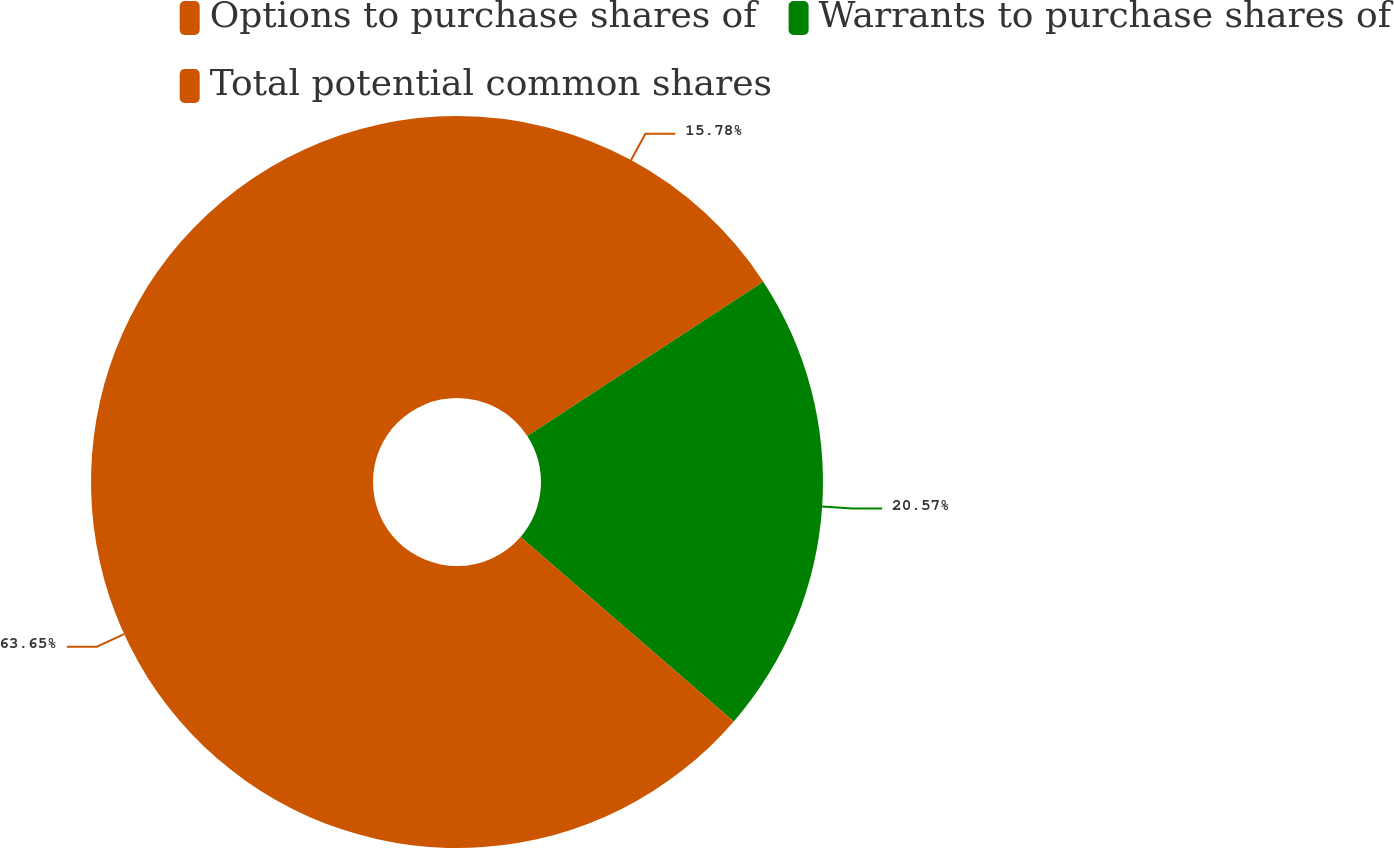Convert chart to OTSL. <chart><loc_0><loc_0><loc_500><loc_500><pie_chart><fcel>Options to purchase shares of<fcel>Warrants to purchase shares of<fcel>Total potential common shares<nl><fcel>15.78%<fcel>20.57%<fcel>63.65%<nl></chart> 